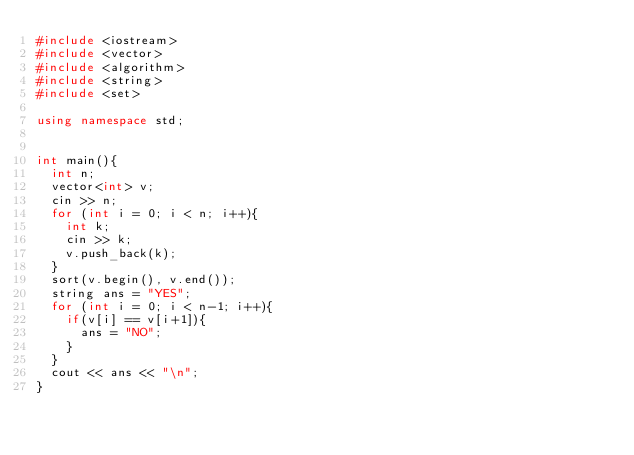Convert code to text. <code><loc_0><loc_0><loc_500><loc_500><_C++_>#include <iostream>
#include <vector>
#include <algorithm>
#include <string> 
#include <set>

using namespace std;

  
int main(){
  int n;
  vector<int> v;
  cin >> n;
  for (int i = 0; i < n; i++){
    int k;
    cin >> k;
    v.push_back(k);
  }
  sort(v.begin(), v.end());
  string ans = "YES";
  for (int i = 0; i < n-1; i++){
    if(v[i] == v[i+1]){
      ans = "NO";
    }
  }
  cout << ans << "\n";
}
</code> 